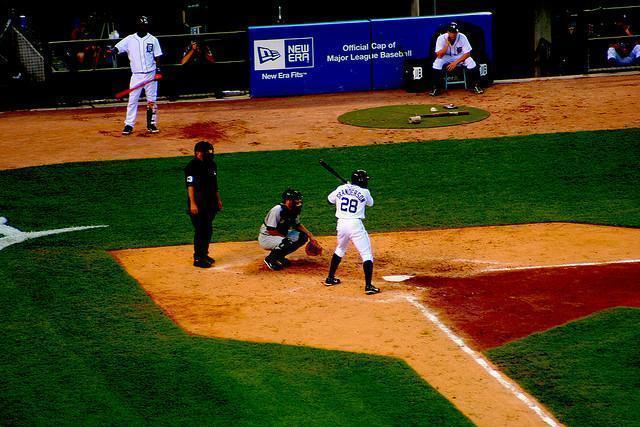The person wearing what color of shirt officiates the game?
Choose the correct response, then elucidate: 'Answer: answer
Rationale: rationale.'
Options: Blue, white, grey, black. Answer: black.
Rationale: Baseball umpires always wear black. 